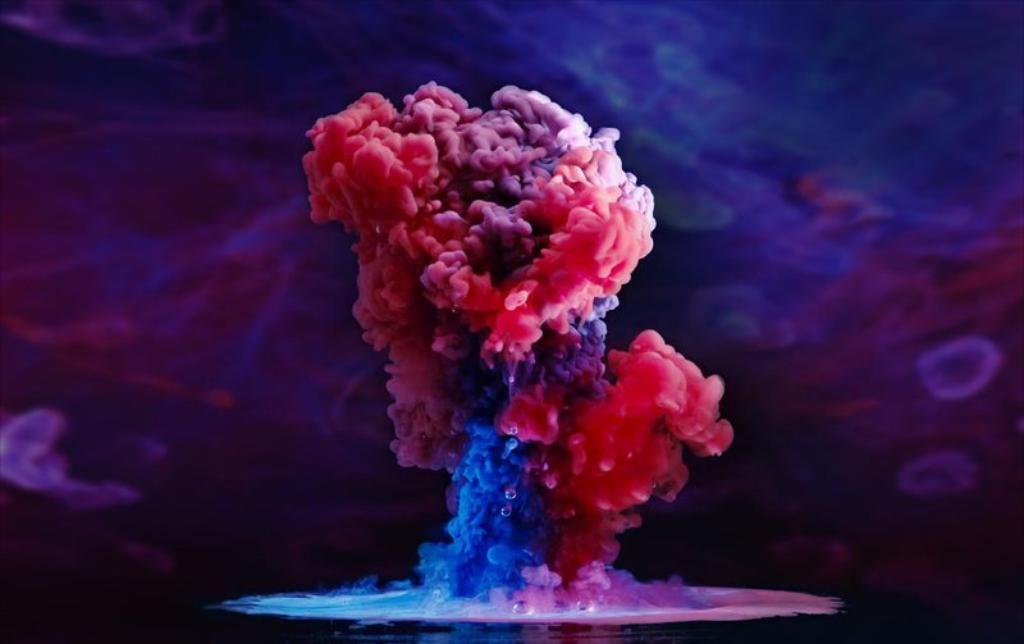What colors of smoke are visible in the image? There is red and blue smoke in the image. Can you describe the background of the image? The background behind the smoke is blurry. What type of current is flowing through the quilt in the image? There is no quilt or current present in the image; it features red and blue smoke with a blurry background. 